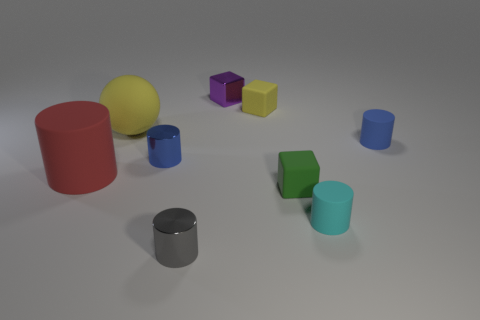Subtract all small gray shiny cylinders. How many cylinders are left? 4 Subtract all red cylinders. How many cylinders are left? 4 Subtract all purple cylinders. Subtract all gray balls. How many cylinders are left? 5 Add 1 large red metallic things. How many objects exist? 10 Subtract all balls. How many objects are left? 8 Subtract 1 gray cylinders. How many objects are left? 8 Subtract all red metal spheres. Subtract all tiny blue objects. How many objects are left? 7 Add 3 green matte things. How many green matte things are left? 4 Add 9 small green things. How many small green things exist? 10 